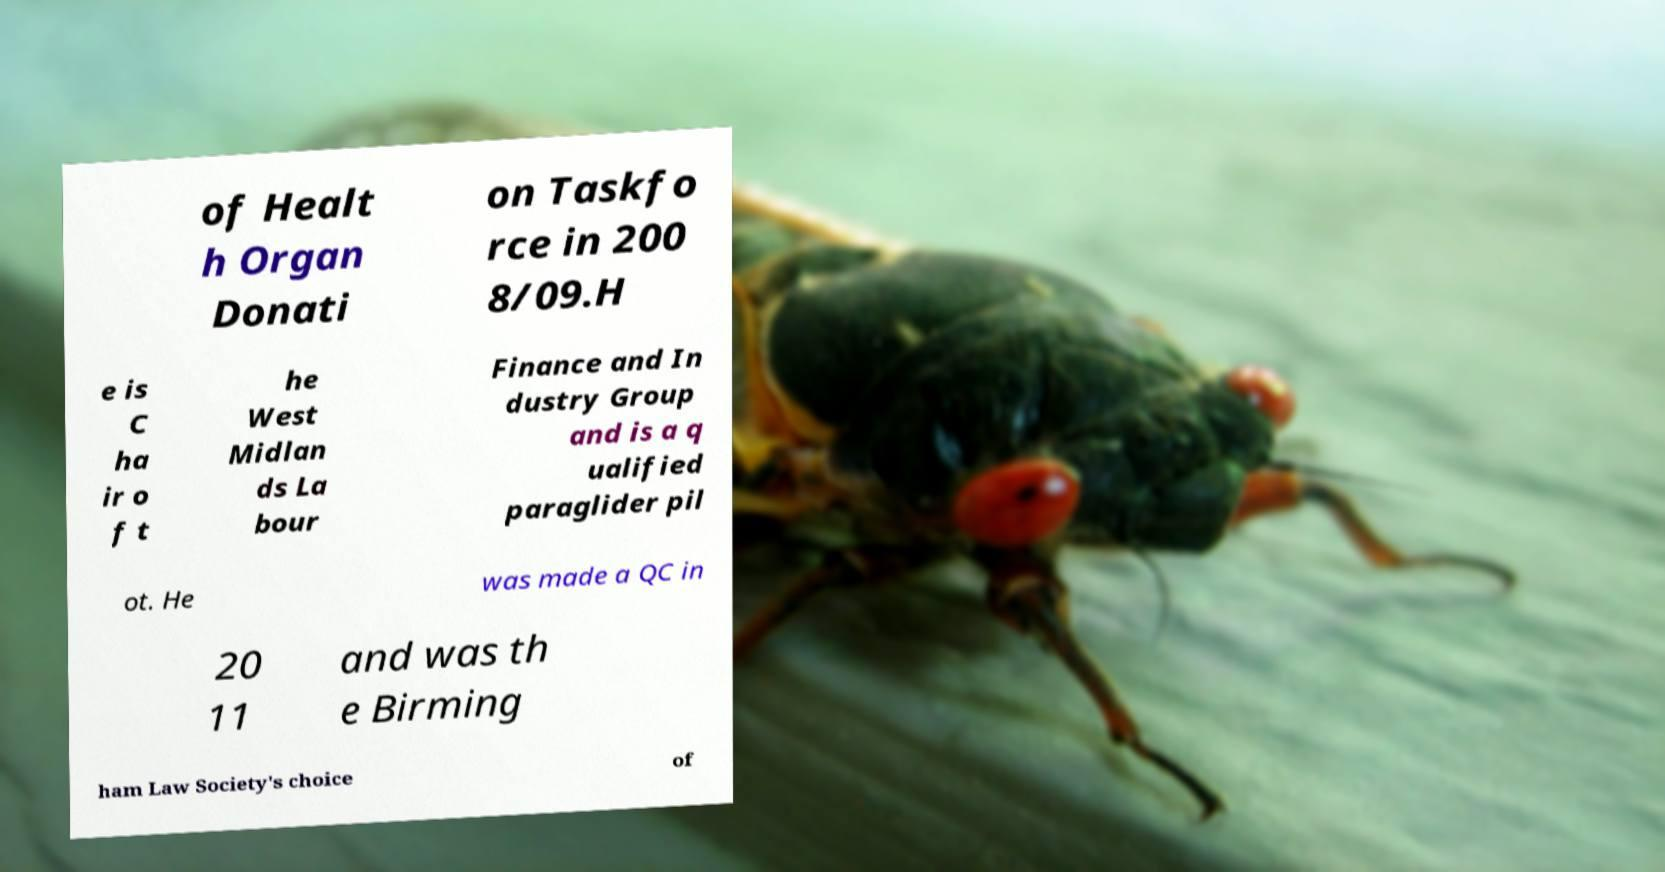What messages or text are displayed in this image? I need them in a readable, typed format. of Healt h Organ Donati on Taskfo rce in 200 8/09.H e is C ha ir o f t he West Midlan ds La bour Finance and In dustry Group and is a q ualified paraglider pil ot. He was made a QC in 20 11 and was th e Birming ham Law Society's choice of 